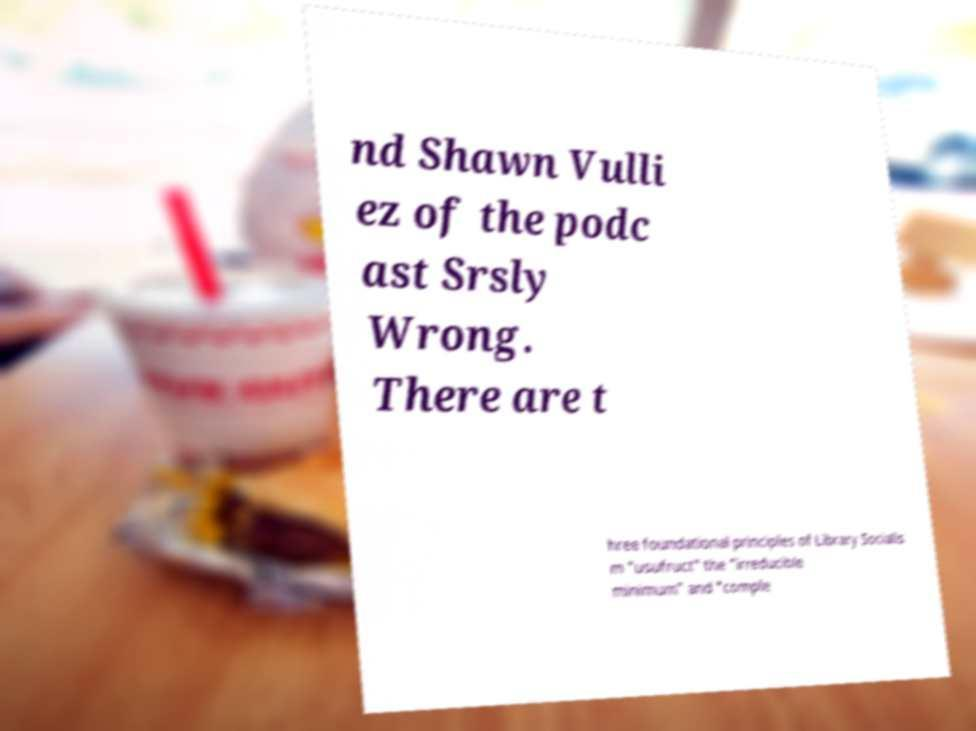Please read and relay the text visible in this image. What does it say? nd Shawn Vulli ez of the podc ast Srsly Wrong. There are t hree foundational principles of Library Socialis m "usufruct" the "irreducible minimum" and "comple 